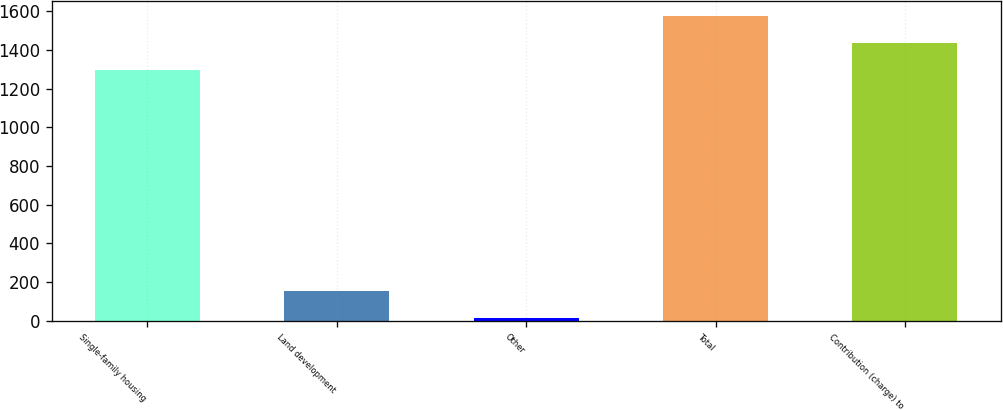Convert chart to OTSL. <chart><loc_0><loc_0><loc_500><loc_500><bar_chart><fcel>Single-family housing<fcel>Land development<fcel>Other<fcel>Total<fcel>Contribution (charge) to<nl><fcel>1294<fcel>154.3<fcel>15<fcel>1572.6<fcel>1433.3<nl></chart> 